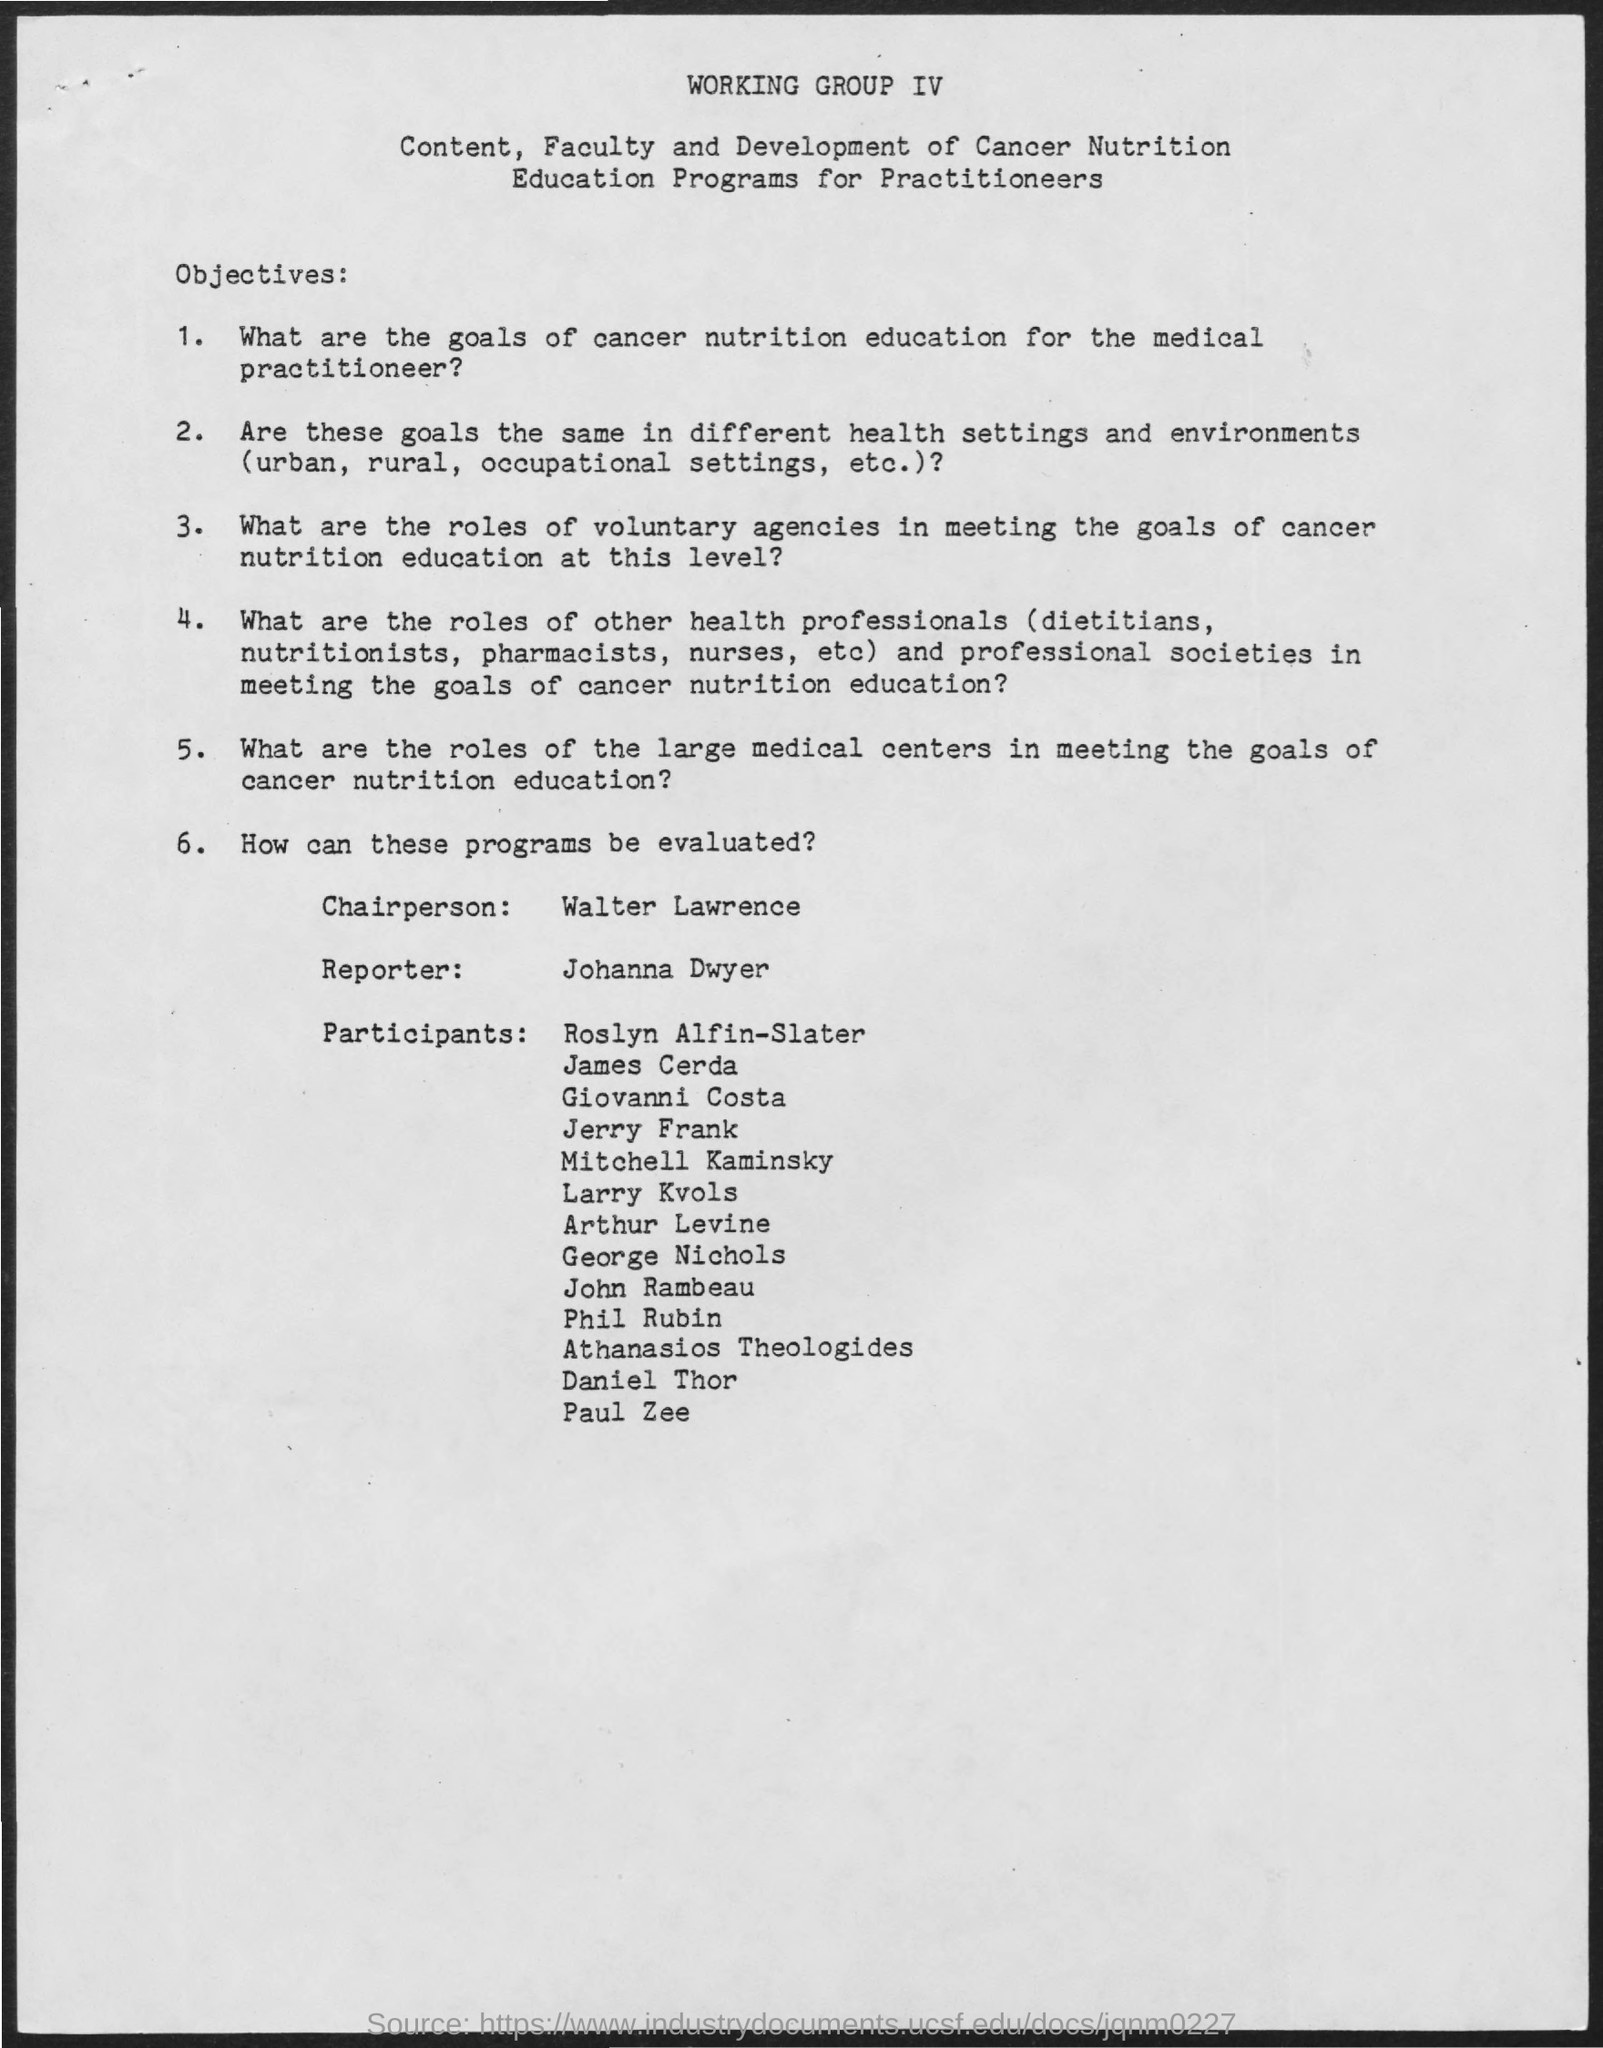What is the name of chairperson mentioned ?
Keep it short and to the point. WALTER LAWRENCE. What  is the name of the reporter mentioned ?
Provide a short and direct response. Johanna dwyer. 